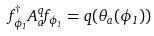<formula> <loc_0><loc_0><loc_500><loc_500>f _ { \phi _ { 1 } } ^ { \dagger } A _ { a } ^ { q } f _ { \phi _ { 1 } } = q ( \theta _ { a } ( \phi _ { 1 } ) )</formula> 